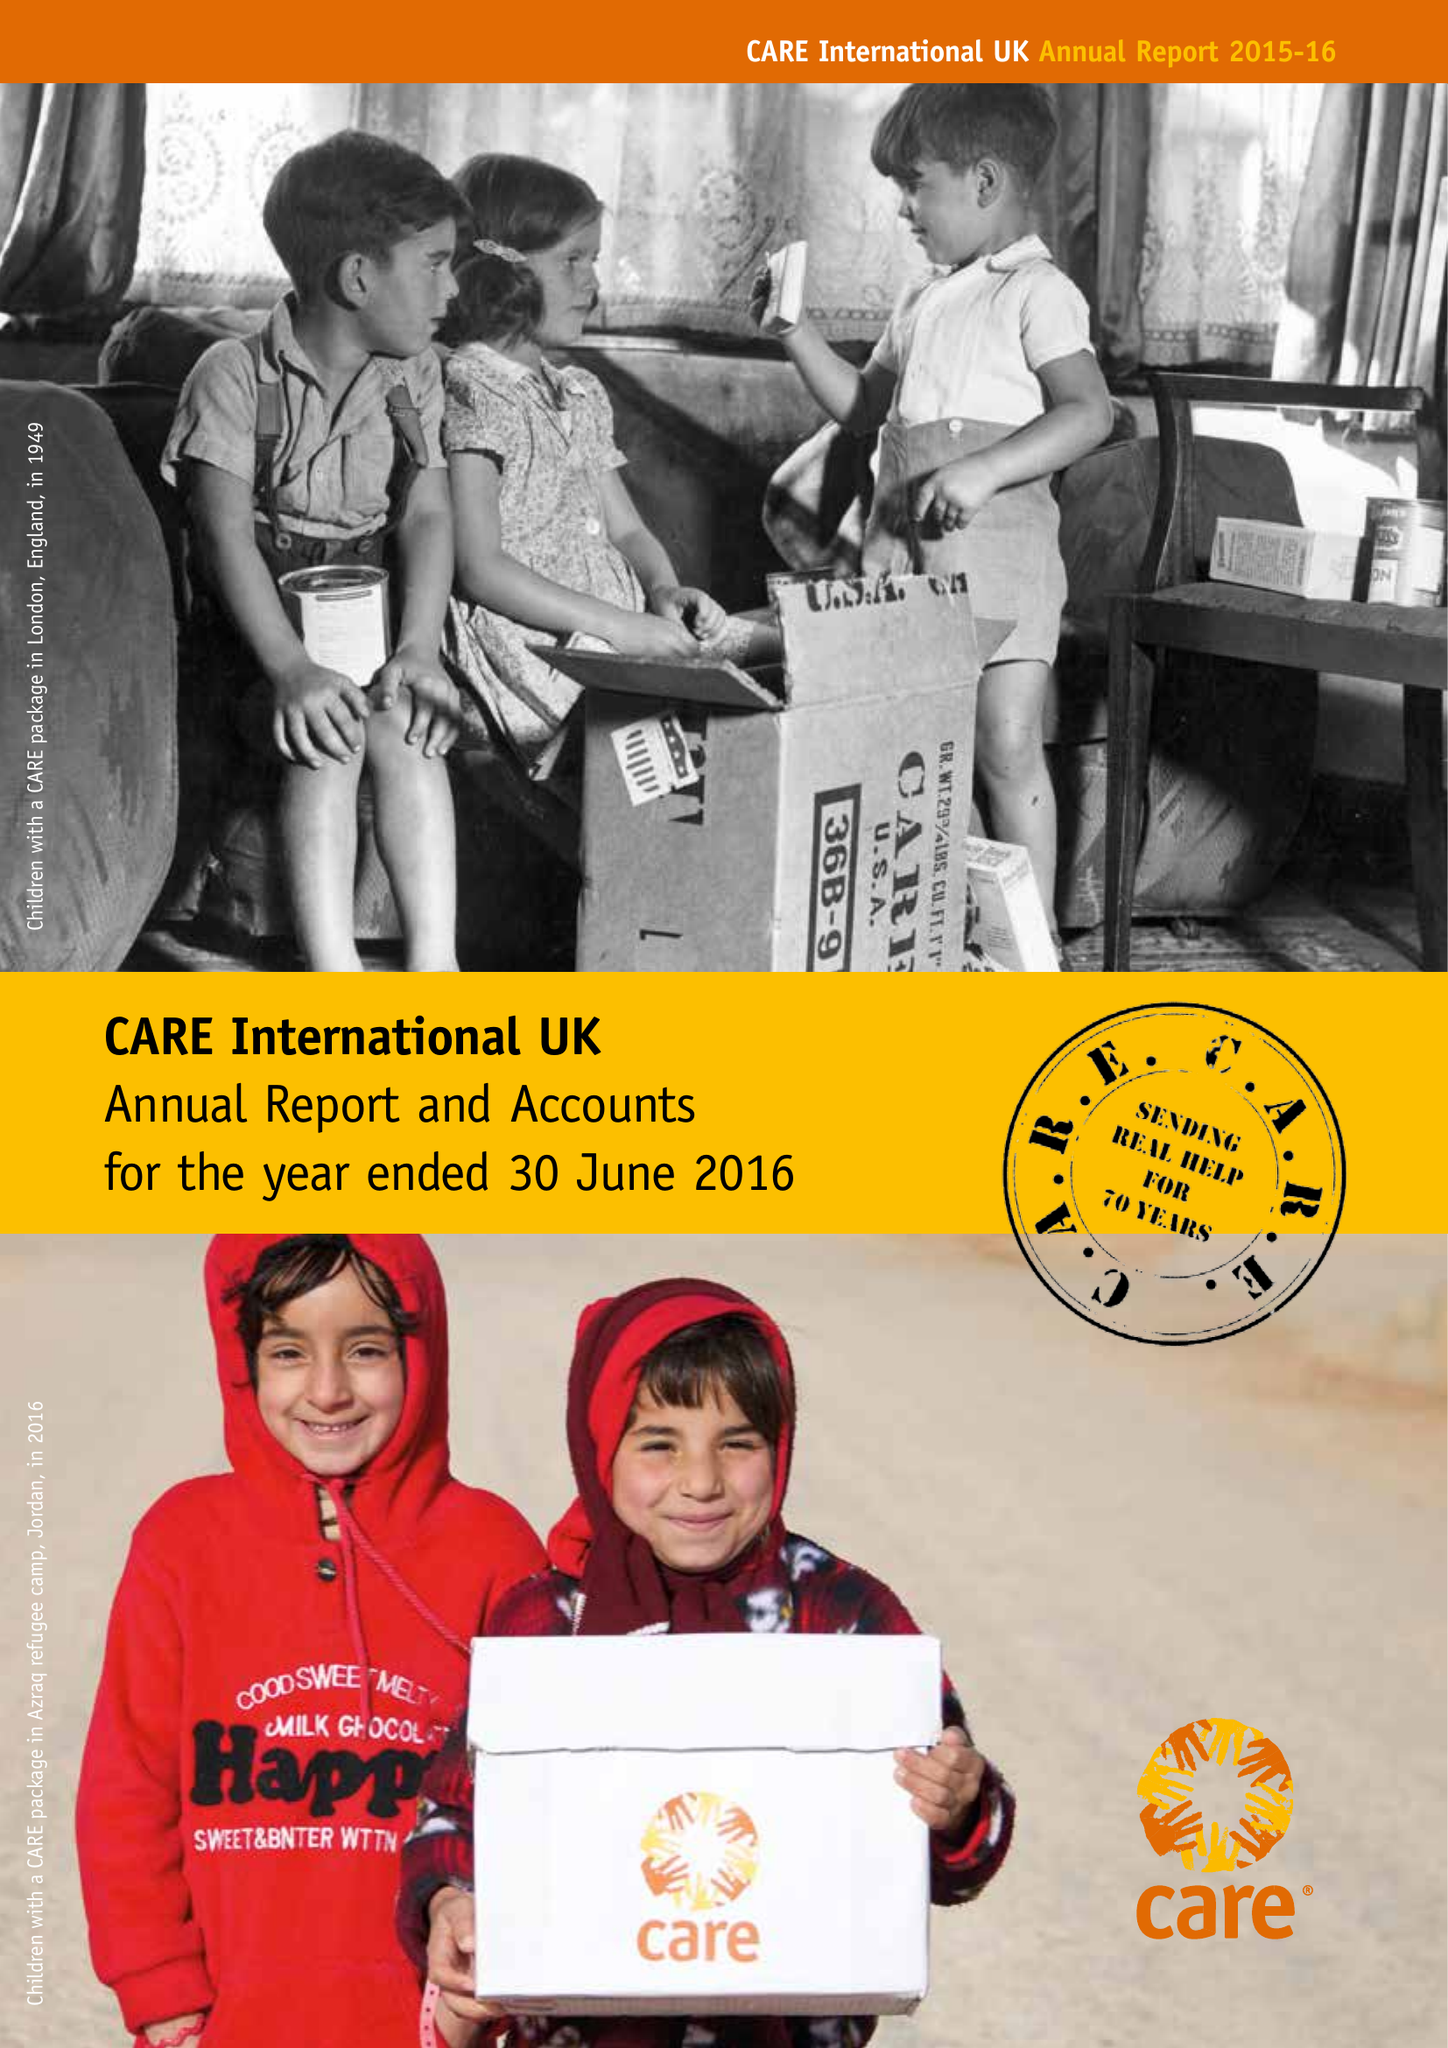What is the value for the income_annually_in_british_pounds?
Answer the question using a single word or phrase. 78172000.00 